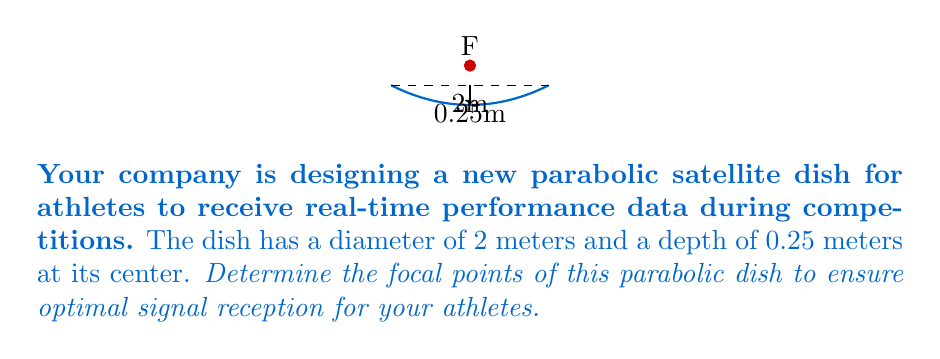Could you help me with this problem? To find the focal points of the parabolic dish, we'll follow these steps:

1) The general equation of a parabola with vertex at the origin and axis of symmetry along the y-axis is:

   $$y = \frac{1}{4p}x^2$$

   where $p$ is the focal length (distance from vertex to focus).

2) We know the dish's diameter (2m) and depth (0.25m). Let's set up our coordinate system with the vertex at (0, -0.25) and the x-axis at the dish's rim.

3) The equation of our parabola will be:

   $$y = \frac{1}{4p}x^2 - 0.25$$

4) We can find $p$ by using the point (1, 0), which lies on the rim of the dish:

   $$0 = \frac{1}{4p}(1)^2 - 0.25$$
   $$0.25 = \frac{1}{4p}$$
   $$p = 1$$

5) The focal length is 1 meter. Since our vertex is at (0, -0.25), the focal point will be 1 meter above the vertex.

6) Therefore, the coordinates of the focal point are (0, 0.75).
Answer: (0, 0.75) 